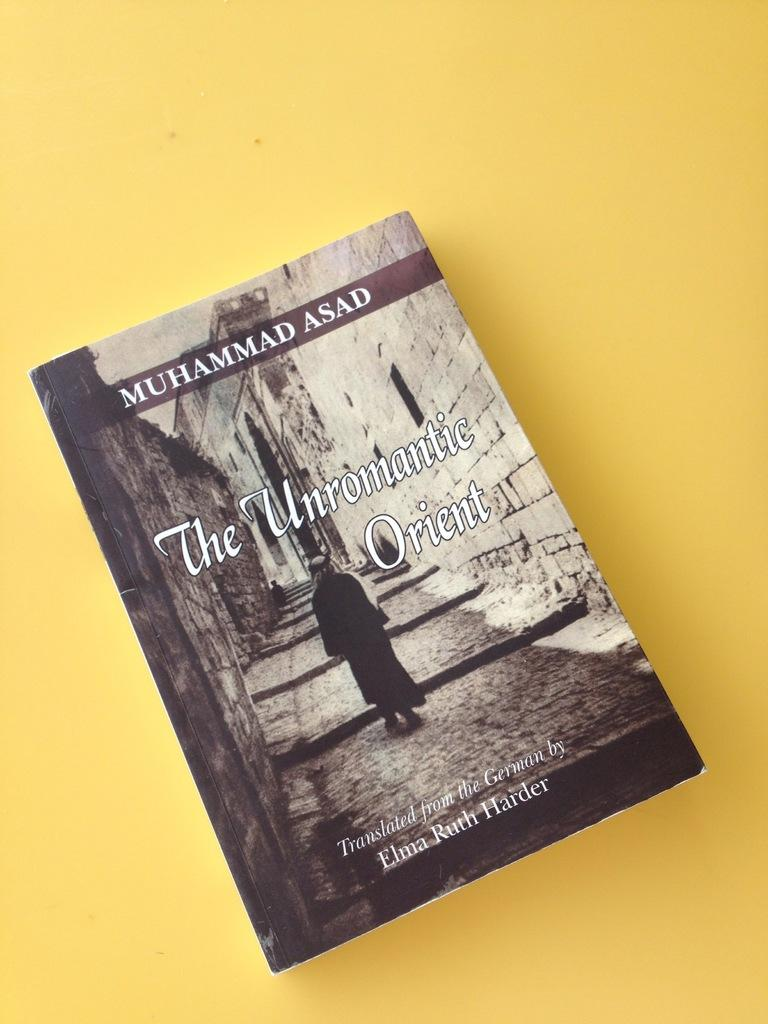Provide a one-sentence caption for the provided image. The Unromantic Orient written by Asad sits on a yellow background. 